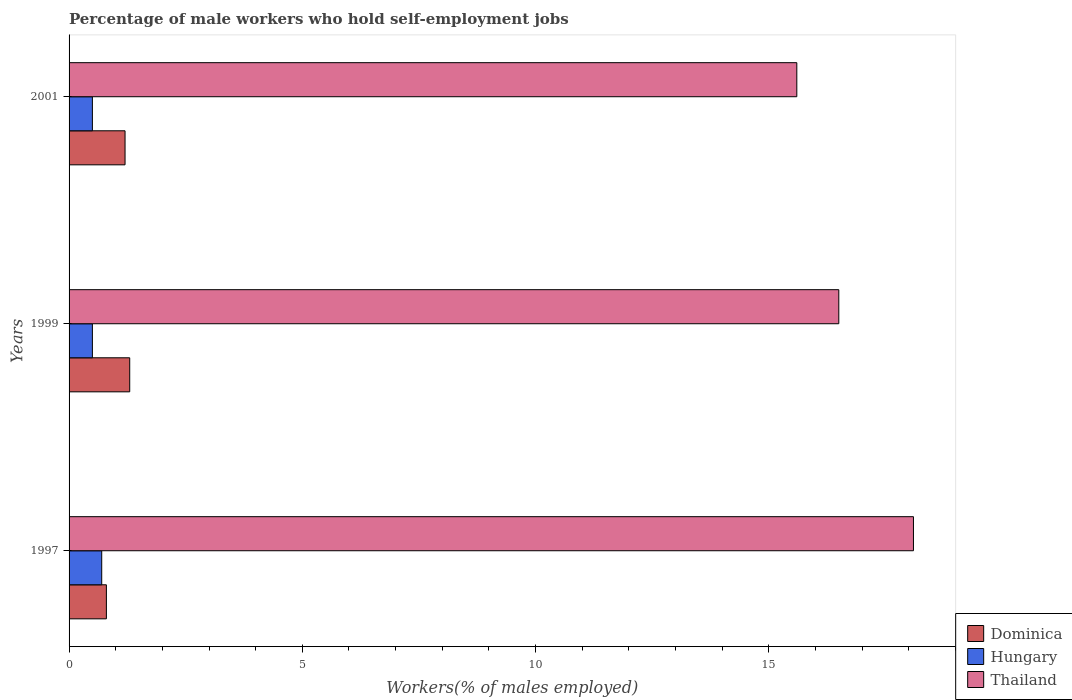How many different coloured bars are there?
Your answer should be compact. 3. Are the number of bars per tick equal to the number of legend labels?
Your answer should be compact. Yes. Are the number of bars on each tick of the Y-axis equal?
Your response must be concise. Yes. How many bars are there on the 3rd tick from the bottom?
Provide a succinct answer. 3. What is the label of the 1st group of bars from the top?
Your answer should be very brief. 2001. In how many cases, is the number of bars for a given year not equal to the number of legend labels?
Offer a very short reply. 0. What is the percentage of self-employed male workers in Hungary in 1997?
Your answer should be very brief. 0.7. Across all years, what is the maximum percentage of self-employed male workers in Hungary?
Give a very brief answer. 0.7. In which year was the percentage of self-employed male workers in Hungary minimum?
Your response must be concise. 1999. What is the total percentage of self-employed male workers in Hungary in the graph?
Make the answer very short. 1.7. What is the difference between the percentage of self-employed male workers in Hungary in 1997 and that in 1999?
Your response must be concise. 0.2. What is the difference between the percentage of self-employed male workers in Thailand in 1997 and the percentage of self-employed male workers in Hungary in 1999?
Make the answer very short. 17.6. What is the average percentage of self-employed male workers in Hungary per year?
Make the answer very short. 0.57. In the year 1997, what is the difference between the percentage of self-employed male workers in Hungary and percentage of self-employed male workers in Dominica?
Give a very brief answer. -0.1. What is the ratio of the percentage of self-employed male workers in Thailand in 1999 to that in 2001?
Keep it short and to the point. 1.06. Is the percentage of self-employed male workers in Hungary in 1997 less than that in 2001?
Provide a short and direct response. No. What is the difference between the highest and the second highest percentage of self-employed male workers in Hungary?
Give a very brief answer. 0.2. What is the difference between the highest and the lowest percentage of self-employed male workers in Hungary?
Give a very brief answer. 0.2. In how many years, is the percentage of self-employed male workers in Hungary greater than the average percentage of self-employed male workers in Hungary taken over all years?
Your response must be concise. 1. What does the 1st bar from the top in 2001 represents?
Your response must be concise. Thailand. What does the 3rd bar from the bottom in 2001 represents?
Keep it short and to the point. Thailand. How many bars are there?
Provide a short and direct response. 9. How many years are there in the graph?
Your answer should be very brief. 3. Are the values on the major ticks of X-axis written in scientific E-notation?
Provide a short and direct response. No. Does the graph contain any zero values?
Your answer should be very brief. No. Where does the legend appear in the graph?
Make the answer very short. Bottom right. What is the title of the graph?
Your answer should be compact. Percentage of male workers who hold self-employment jobs. Does "Costa Rica" appear as one of the legend labels in the graph?
Your response must be concise. No. What is the label or title of the X-axis?
Your answer should be very brief. Workers(% of males employed). What is the label or title of the Y-axis?
Make the answer very short. Years. What is the Workers(% of males employed) of Dominica in 1997?
Your answer should be compact. 0.8. What is the Workers(% of males employed) of Hungary in 1997?
Make the answer very short. 0.7. What is the Workers(% of males employed) in Thailand in 1997?
Ensure brevity in your answer.  18.1. What is the Workers(% of males employed) of Dominica in 1999?
Your answer should be very brief. 1.3. What is the Workers(% of males employed) of Dominica in 2001?
Offer a terse response. 1.2. What is the Workers(% of males employed) of Thailand in 2001?
Offer a very short reply. 15.6. Across all years, what is the maximum Workers(% of males employed) in Dominica?
Your response must be concise. 1.3. Across all years, what is the maximum Workers(% of males employed) in Hungary?
Offer a very short reply. 0.7. Across all years, what is the maximum Workers(% of males employed) of Thailand?
Offer a terse response. 18.1. Across all years, what is the minimum Workers(% of males employed) of Dominica?
Keep it short and to the point. 0.8. Across all years, what is the minimum Workers(% of males employed) in Thailand?
Your answer should be very brief. 15.6. What is the total Workers(% of males employed) in Dominica in the graph?
Your answer should be very brief. 3.3. What is the total Workers(% of males employed) in Hungary in the graph?
Make the answer very short. 1.7. What is the total Workers(% of males employed) of Thailand in the graph?
Ensure brevity in your answer.  50.2. What is the difference between the Workers(% of males employed) of Thailand in 1997 and that in 1999?
Make the answer very short. 1.6. What is the difference between the Workers(% of males employed) in Dominica in 1997 and that in 2001?
Your answer should be compact. -0.4. What is the difference between the Workers(% of males employed) in Hungary in 1997 and that in 2001?
Give a very brief answer. 0.2. What is the difference between the Workers(% of males employed) in Thailand in 1997 and that in 2001?
Ensure brevity in your answer.  2.5. What is the difference between the Workers(% of males employed) in Dominica in 1999 and that in 2001?
Ensure brevity in your answer.  0.1. What is the difference between the Workers(% of males employed) of Dominica in 1997 and the Workers(% of males employed) of Hungary in 1999?
Make the answer very short. 0.3. What is the difference between the Workers(% of males employed) in Dominica in 1997 and the Workers(% of males employed) in Thailand in 1999?
Offer a very short reply. -15.7. What is the difference between the Workers(% of males employed) of Hungary in 1997 and the Workers(% of males employed) of Thailand in 1999?
Give a very brief answer. -15.8. What is the difference between the Workers(% of males employed) in Dominica in 1997 and the Workers(% of males employed) in Hungary in 2001?
Provide a succinct answer. 0.3. What is the difference between the Workers(% of males employed) of Dominica in 1997 and the Workers(% of males employed) of Thailand in 2001?
Your answer should be compact. -14.8. What is the difference between the Workers(% of males employed) in Hungary in 1997 and the Workers(% of males employed) in Thailand in 2001?
Give a very brief answer. -14.9. What is the difference between the Workers(% of males employed) in Dominica in 1999 and the Workers(% of males employed) in Thailand in 2001?
Ensure brevity in your answer.  -14.3. What is the difference between the Workers(% of males employed) in Hungary in 1999 and the Workers(% of males employed) in Thailand in 2001?
Ensure brevity in your answer.  -15.1. What is the average Workers(% of males employed) of Dominica per year?
Offer a very short reply. 1.1. What is the average Workers(% of males employed) in Hungary per year?
Provide a short and direct response. 0.57. What is the average Workers(% of males employed) in Thailand per year?
Offer a very short reply. 16.73. In the year 1997, what is the difference between the Workers(% of males employed) in Dominica and Workers(% of males employed) in Hungary?
Offer a very short reply. 0.1. In the year 1997, what is the difference between the Workers(% of males employed) in Dominica and Workers(% of males employed) in Thailand?
Offer a terse response. -17.3. In the year 1997, what is the difference between the Workers(% of males employed) of Hungary and Workers(% of males employed) of Thailand?
Keep it short and to the point. -17.4. In the year 1999, what is the difference between the Workers(% of males employed) of Dominica and Workers(% of males employed) of Hungary?
Keep it short and to the point. 0.8. In the year 1999, what is the difference between the Workers(% of males employed) in Dominica and Workers(% of males employed) in Thailand?
Your answer should be very brief. -15.2. In the year 1999, what is the difference between the Workers(% of males employed) in Hungary and Workers(% of males employed) in Thailand?
Your response must be concise. -16. In the year 2001, what is the difference between the Workers(% of males employed) of Dominica and Workers(% of males employed) of Hungary?
Provide a succinct answer. 0.7. In the year 2001, what is the difference between the Workers(% of males employed) in Dominica and Workers(% of males employed) in Thailand?
Keep it short and to the point. -14.4. In the year 2001, what is the difference between the Workers(% of males employed) of Hungary and Workers(% of males employed) of Thailand?
Your answer should be very brief. -15.1. What is the ratio of the Workers(% of males employed) of Dominica in 1997 to that in 1999?
Give a very brief answer. 0.62. What is the ratio of the Workers(% of males employed) of Hungary in 1997 to that in 1999?
Offer a very short reply. 1.4. What is the ratio of the Workers(% of males employed) of Thailand in 1997 to that in 1999?
Your answer should be very brief. 1.1. What is the ratio of the Workers(% of males employed) of Dominica in 1997 to that in 2001?
Your answer should be very brief. 0.67. What is the ratio of the Workers(% of males employed) in Hungary in 1997 to that in 2001?
Your answer should be compact. 1.4. What is the ratio of the Workers(% of males employed) in Thailand in 1997 to that in 2001?
Your response must be concise. 1.16. What is the ratio of the Workers(% of males employed) of Thailand in 1999 to that in 2001?
Your answer should be compact. 1.06. What is the difference between the highest and the second highest Workers(% of males employed) in Dominica?
Make the answer very short. 0.1. What is the difference between the highest and the second highest Workers(% of males employed) of Hungary?
Provide a succinct answer. 0.2. 